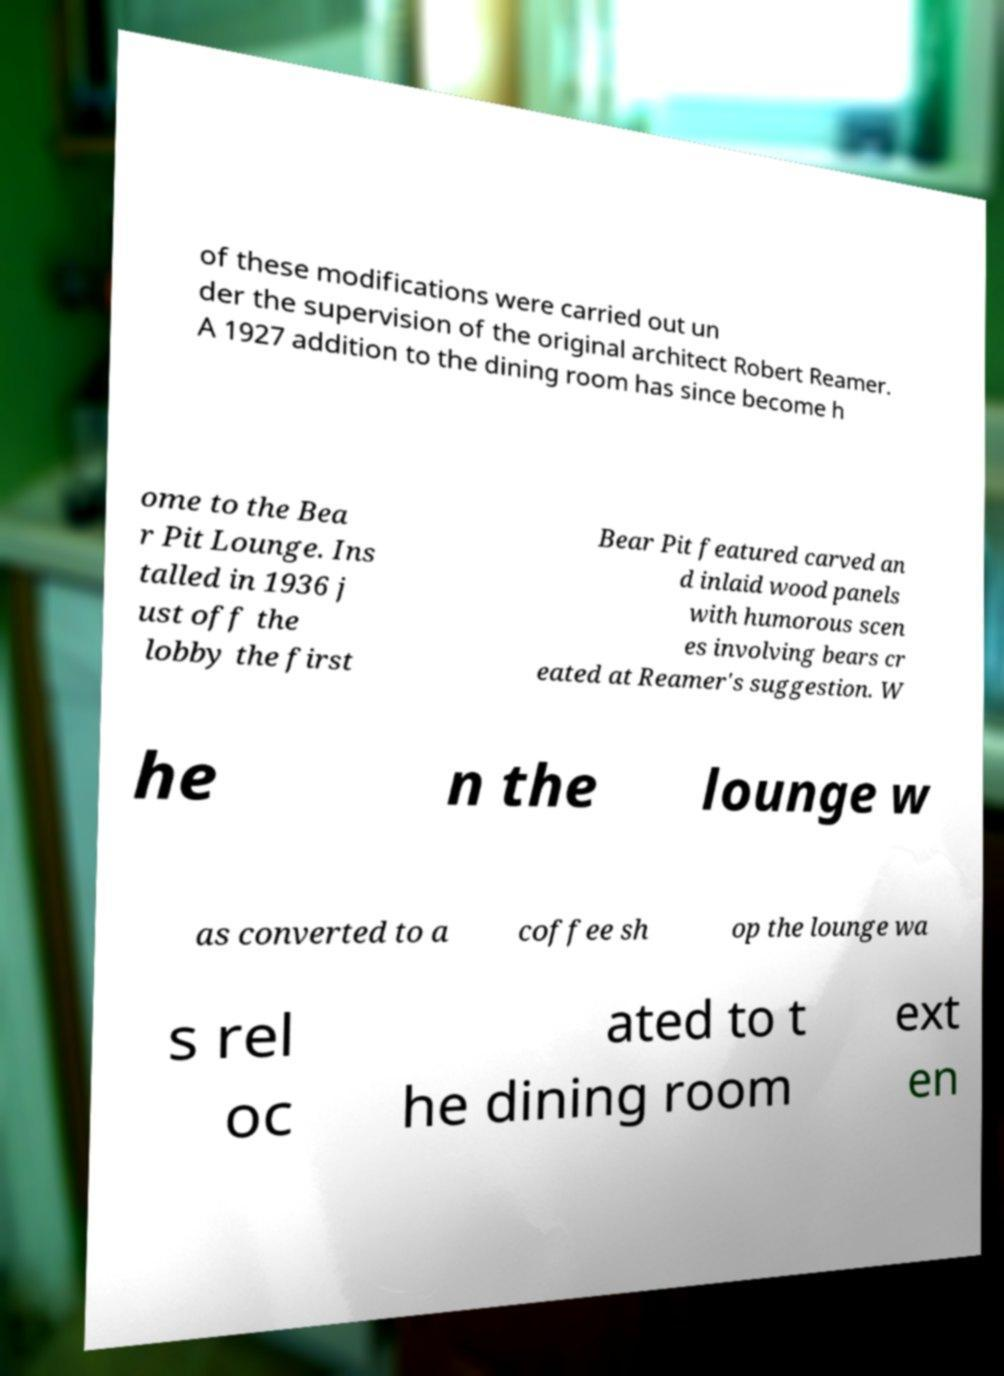For documentation purposes, I need the text within this image transcribed. Could you provide that? of these modifications were carried out un der the supervision of the original architect Robert Reamer. A 1927 addition to the dining room has since become h ome to the Bea r Pit Lounge. Ins talled in 1936 j ust off the lobby the first Bear Pit featured carved an d inlaid wood panels with humorous scen es involving bears cr eated at Reamer's suggestion. W he n the lounge w as converted to a coffee sh op the lounge wa s rel oc ated to t he dining room ext en 